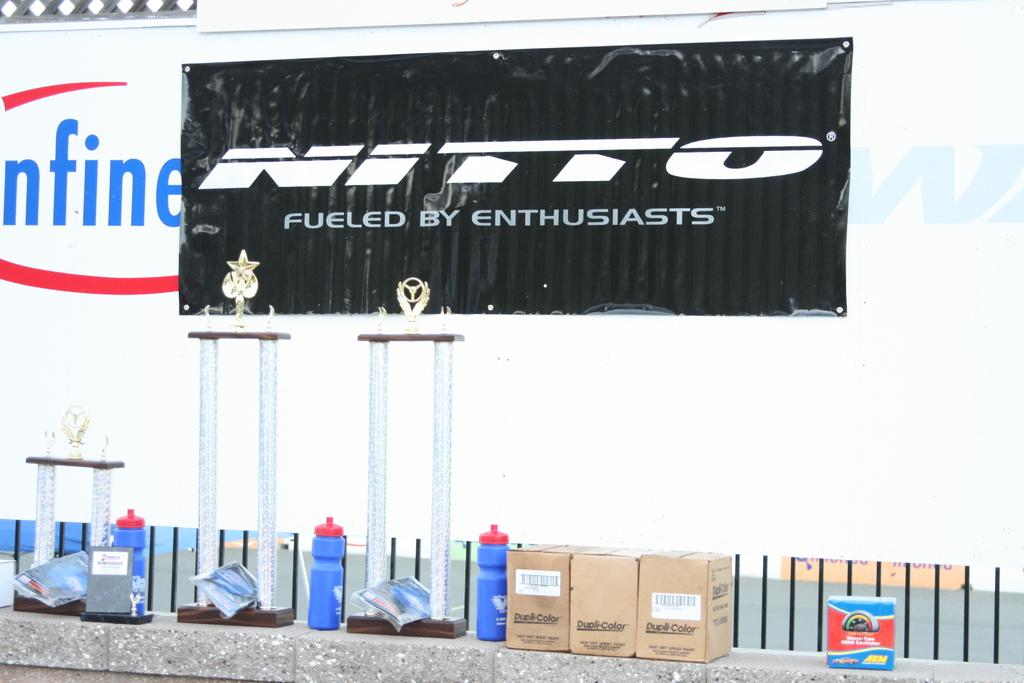Provide a one-sentence caption for the provided image. Blue water bottles on a brick wall in front of a sign that says Nitto Fueled By Enthusiasts. 